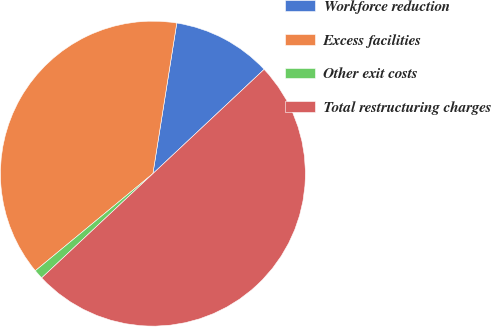<chart> <loc_0><loc_0><loc_500><loc_500><pie_chart><fcel>Workforce reduction<fcel>Excess facilities<fcel>Other exit costs<fcel>Total restructuring charges<nl><fcel>10.51%<fcel>38.49%<fcel>1.0%<fcel>50.0%<nl></chart> 